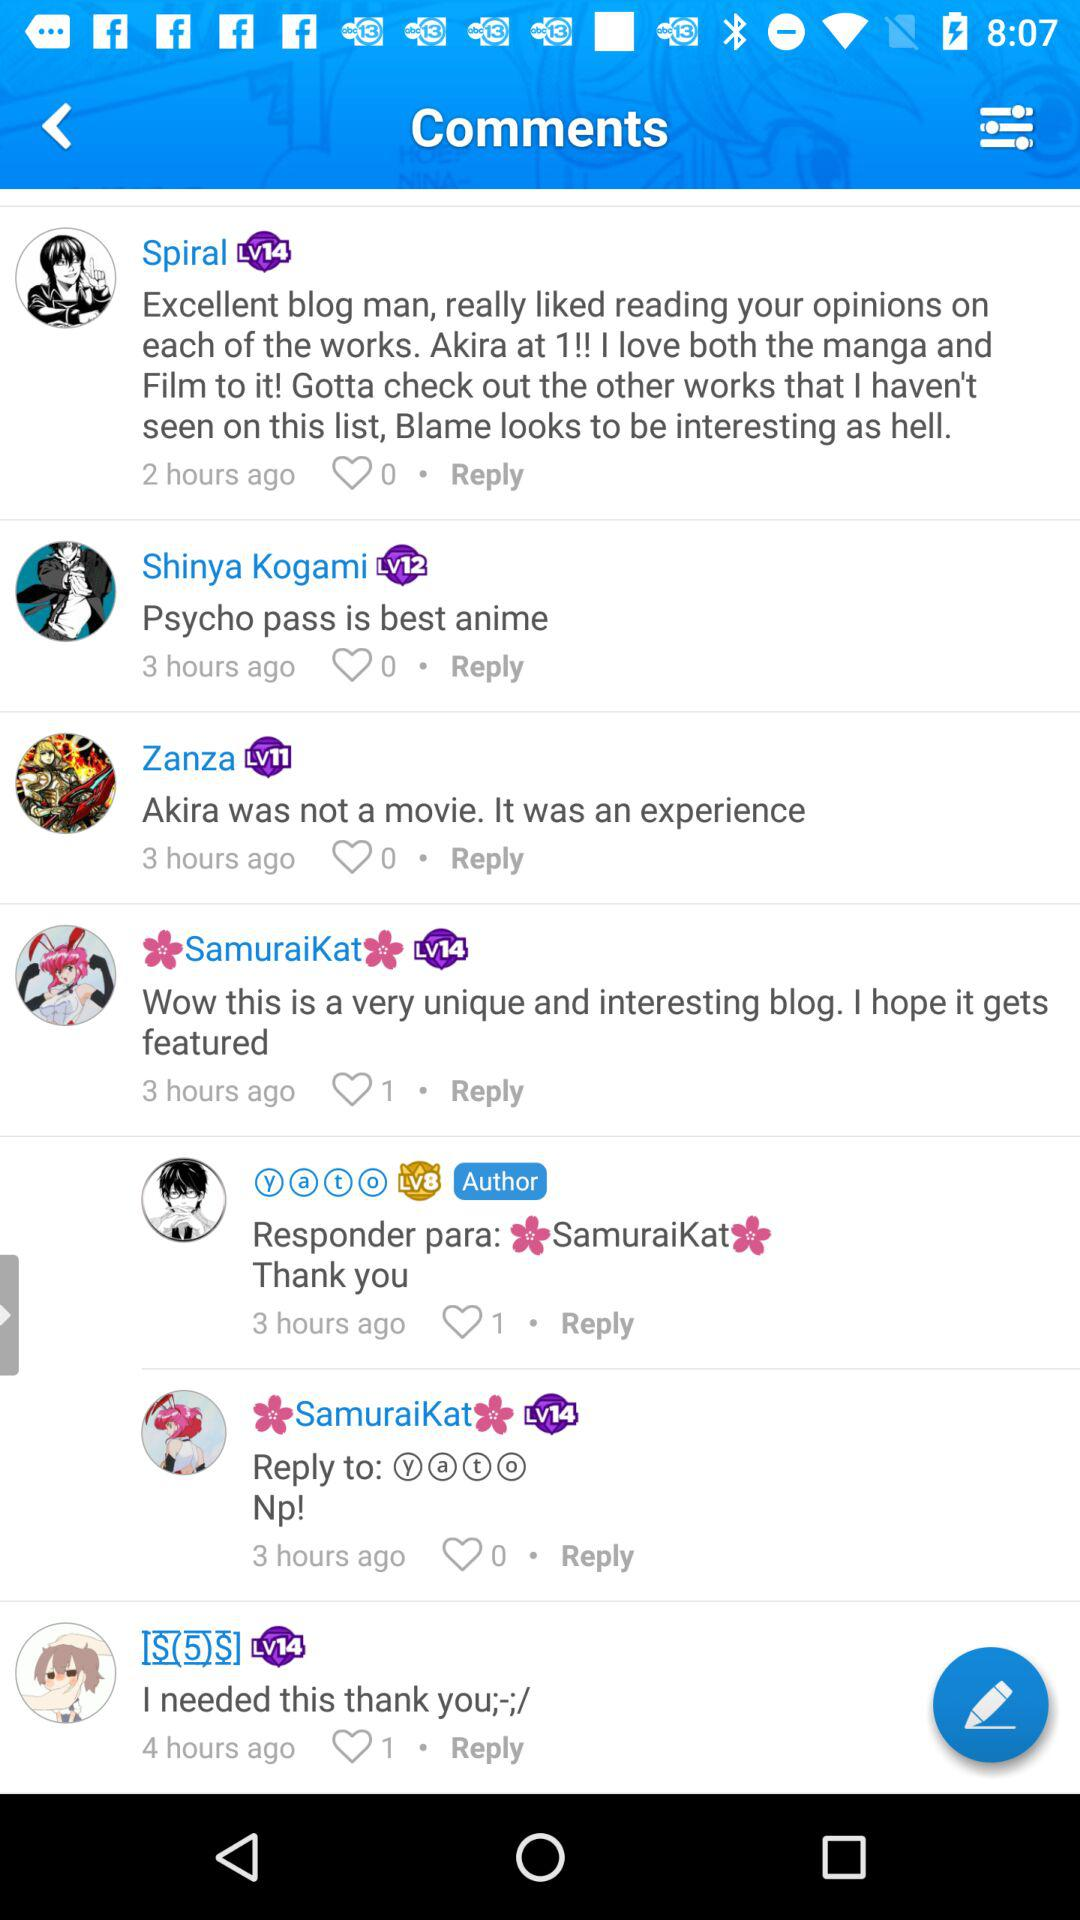Is there any comment on Shinya Kogami post?
When the provided information is insufficient, respond with <no answer>. <no answer> 